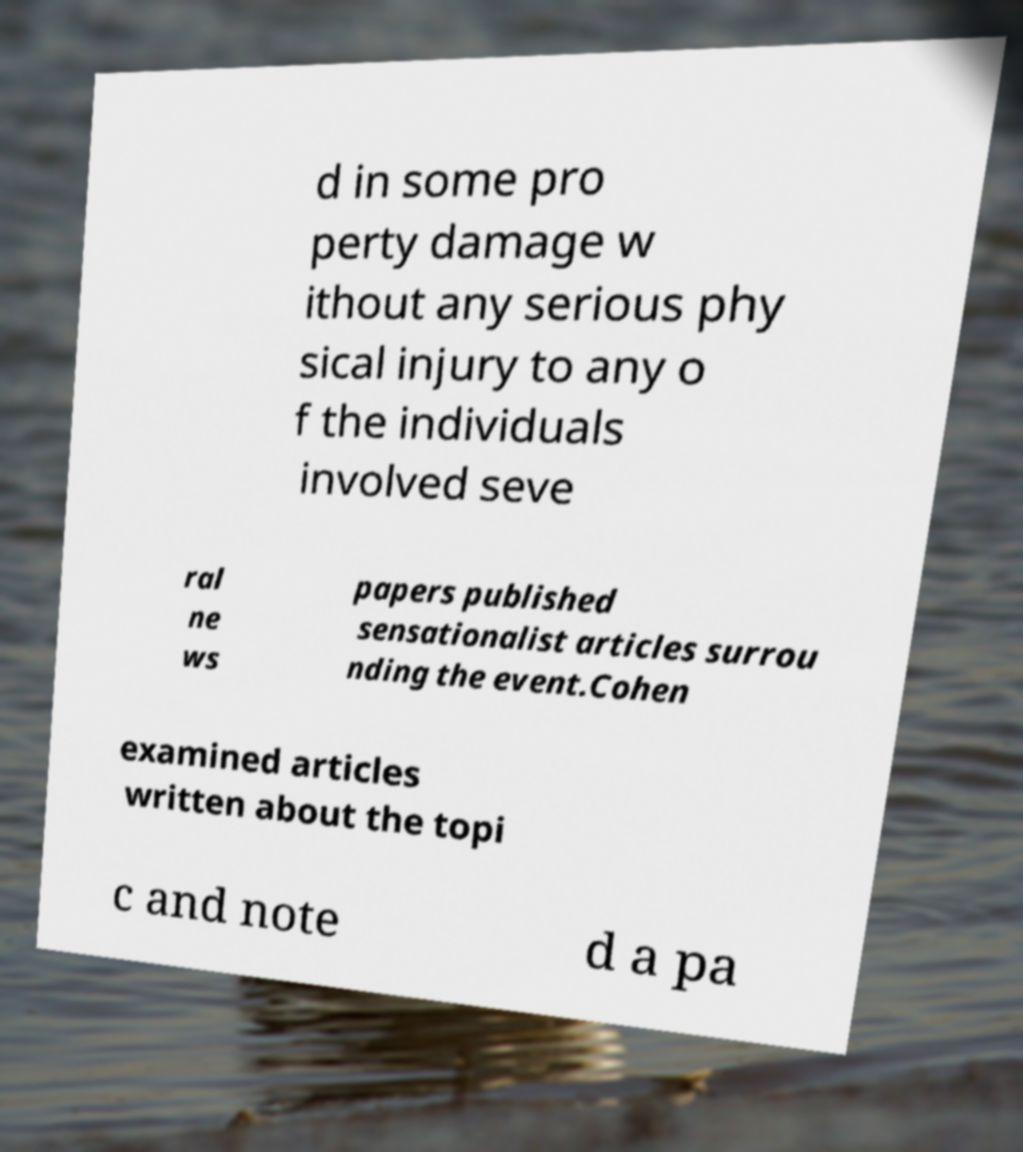I need the written content from this picture converted into text. Can you do that? d in some pro perty damage w ithout any serious phy sical injury to any o f the individuals involved seve ral ne ws papers published sensationalist articles surrou nding the event.Cohen examined articles written about the topi c and note d a pa 